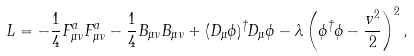<formula> <loc_0><loc_0><loc_500><loc_500>L = - \frac { 1 } { 4 } F _ { \mu \nu } ^ { a } F _ { \mu \nu } ^ { a } - \frac { 1 } { 4 } B _ { \mu \nu } B _ { \mu \nu } + ( D _ { \mu } \phi ) ^ { \dagger } D _ { \mu } \phi - \lambda \left ( \phi ^ { \dagger } \phi - \frac { v ^ { 2 } } { 2 } \right ) ^ { 2 } ,</formula> 